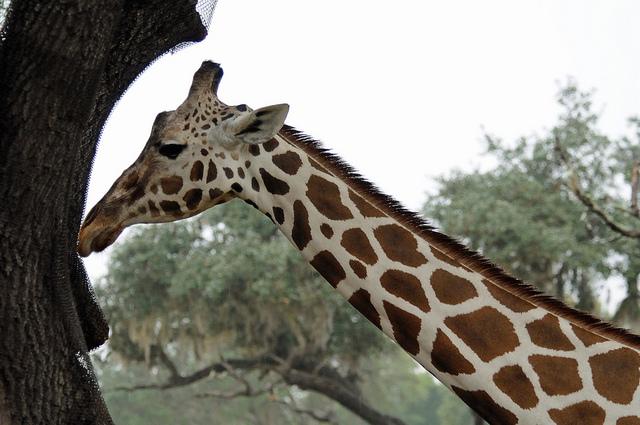What is behind the giraffe?
Give a very brief answer. Trees. Is the giraffe hungry?
Concise answer only. Yes. Is the tree wrapped in something?
Give a very brief answer. Yes. 